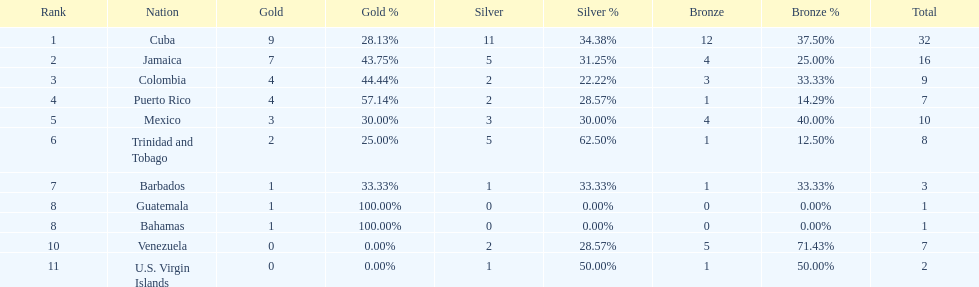Number of teams above 9 medals 3. 